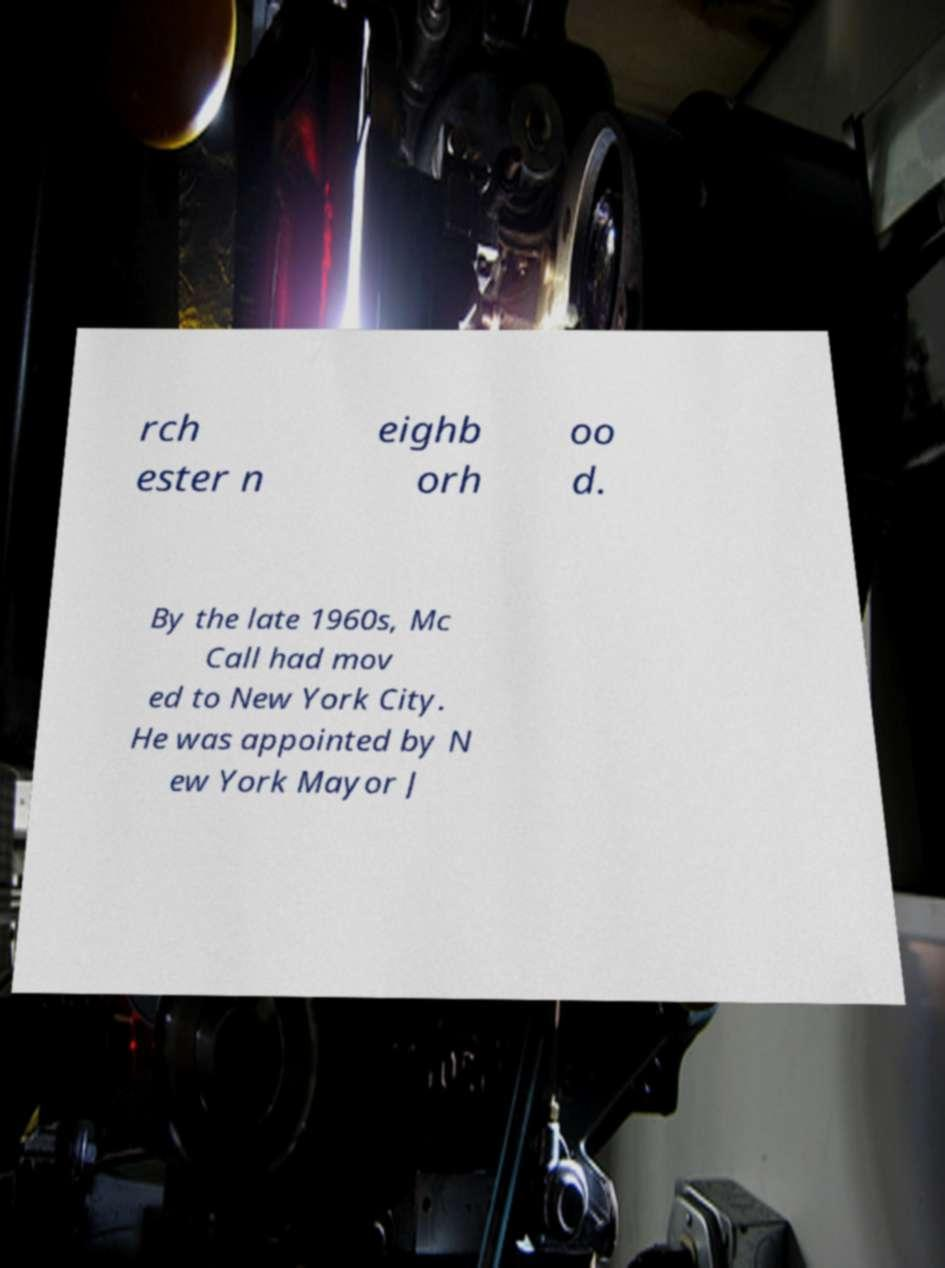Please read and relay the text visible in this image. What does it say? rch ester n eighb orh oo d. By the late 1960s, Mc Call had mov ed to New York City. He was appointed by N ew York Mayor J 